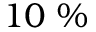<formula> <loc_0><loc_0><loc_500><loc_500>1 0 \%</formula> 